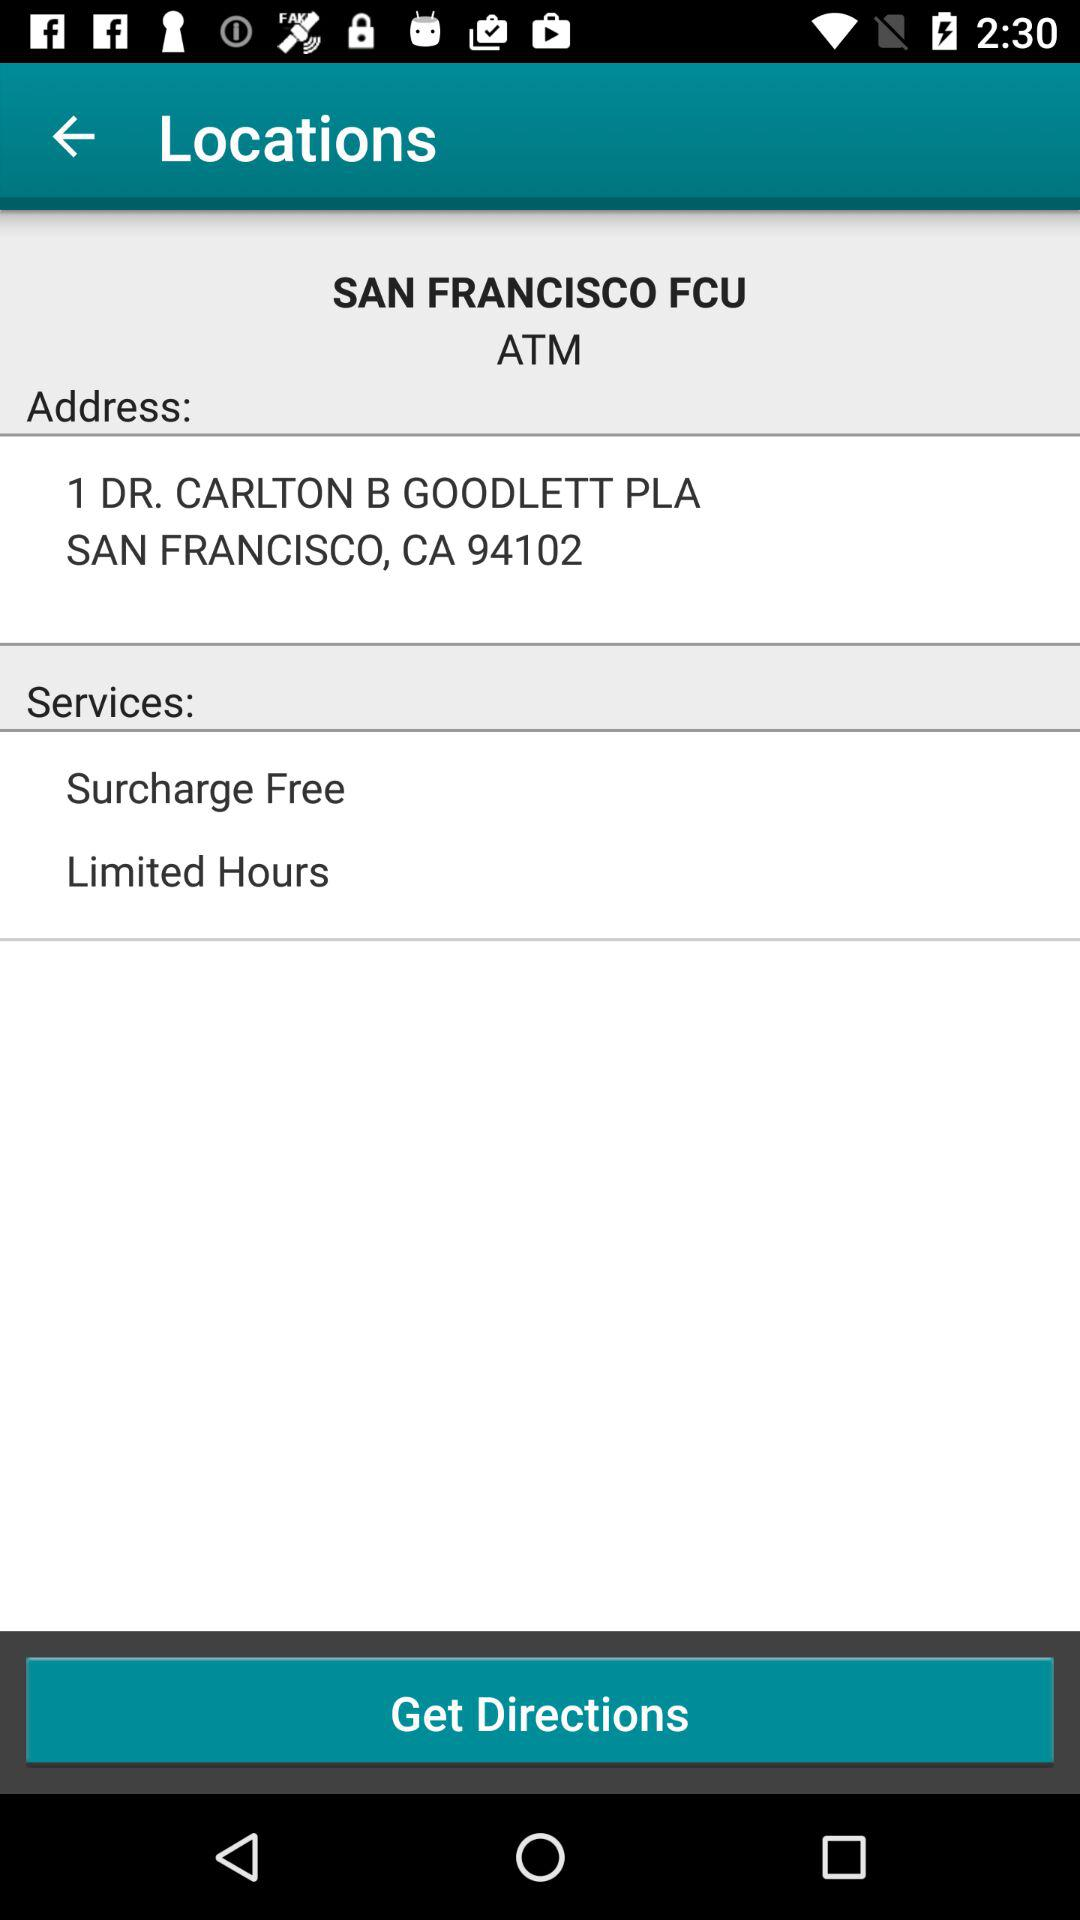What are the services? The services are "Surcharge Free" and "Limited Hours". 